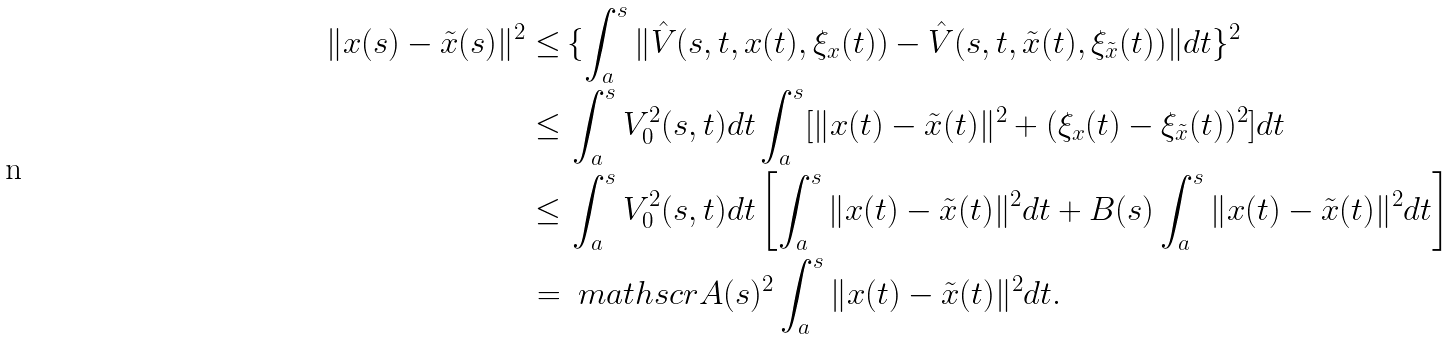<formula> <loc_0><loc_0><loc_500><loc_500>\| x ( s ) - \tilde { x } ( s ) \| ^ { 2 } \leq & \, \{ \int _ { a } ^ { s } \| \hat { V } ( s , t , x ( t ) , \xi _ { x } ( t ) ) - \hat { V } ( s , t , \tilde { x } ( t ) , \xi _ { \tilde { x } } ( t ) ) \| d t \} ^ { 2 } \\ \leq & \, \int _ { a } ^ { s } V _ { 0 } ^ { 2 } ( s , t ) d t \int _ { a } ^ { s } [ \| x ( t ) - \tilde { x } ( t ) \| ^ { 2 } + ( \xi _ { x } ( t ) - \xi _ { \tilde { x } } ( t ) ) ^ { 2 } ] d t \\ \leq & \, \int _ { a } ^ { s } V _ { 0 } ^ { 2 } ( s , t ) d t \left [ \int _ { a } ^ { s } \| x ( t ) - \tilde { x } ( t ) \| ^ { 2 } d t + B ( s ) \int _ { a } ^ { s } \| x ( t ) - \tilde { x } ( t ) \| ^ { 2 } d t \right ] \\ = & \, \ m a t h s c r { A } ( s ) ^ { 2 } \int _ { a } ^ { s } \| x ( t ) - \tilde { x } ( t ) \| ^ { 2 } d t .</formula> 